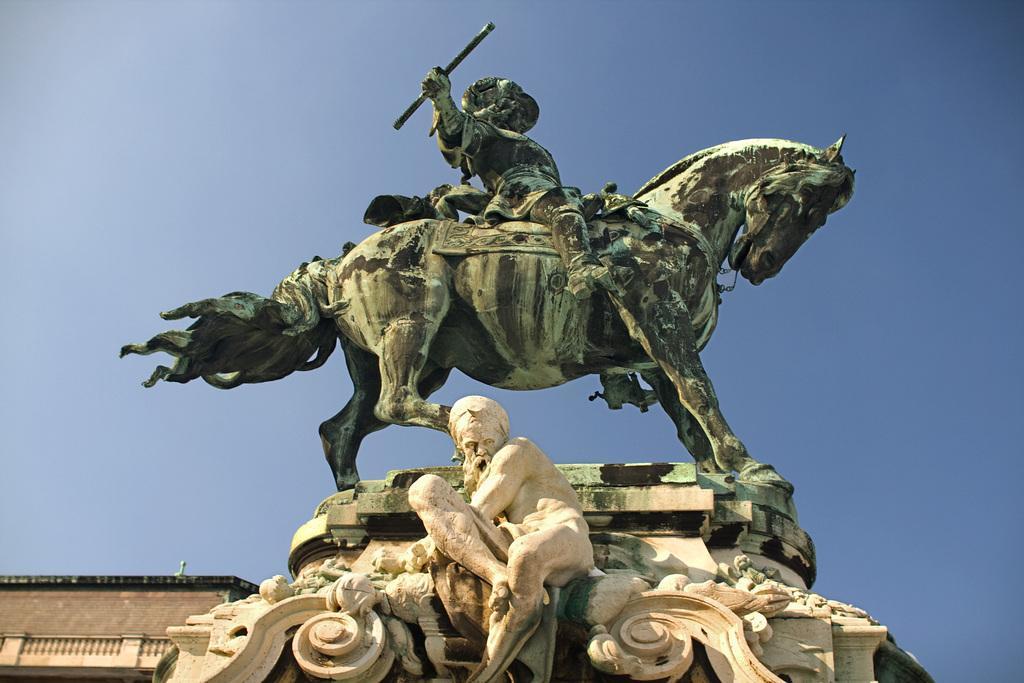Please provide a concise description of this image. In this picture we can see statues of a person sitting on a horse and holding a rod, building and in the background we can see the sky. 